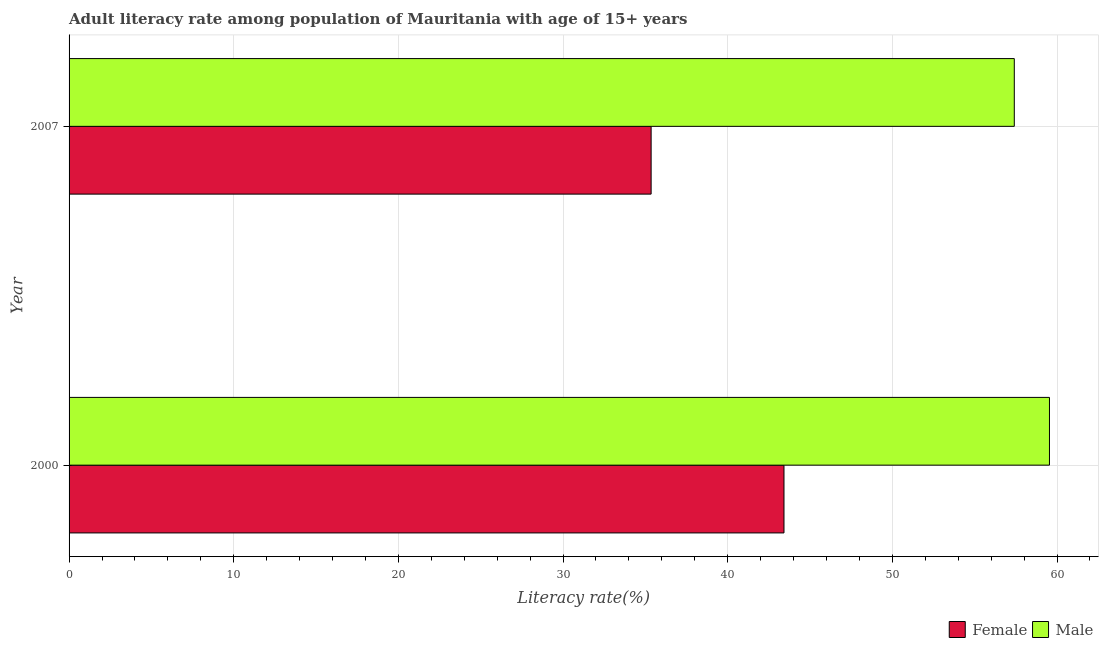How many different coloured bars are there?
Ensure brevity in your answer.  2. Are the number of bars on each tick of the Y-axis equal?
Offer a terse response. Yes. How many bars are there on the 2nd tick from the bottom?
Your response must be concise. 2. What is the label of the 1st group of bars from the top?
Keep it short and to the point. 2007. In how many cases, is the number of bars for a given year not equal to the number of legend labels?
Your response must be concise. 0. What is the male adult literacy rate in 2007?
Provide a succinct answer. 57.4. Across all years, what is the maximum female adult literacy rate?
Provide a succinct answer. 43.42. Across all years, what is the minimum male adult literacy rate?
Keep it short and to the point. 57.4. What is the total male adult literacy rate in the graph?
Your answer should be compact. 116.94. What is the difference between the male adult literacy rate in 2000 and that in 2007?
Ensure brevity in your answer.  2.14. What is the difference between the female adult literacy rate in 2000 and the male adult literacy rate in 2007?
Your response must be concise. -13.99. What is the average male adult literacy rate per year?
Your answer should be compact. 58.47. In the year 2007, what is the difference between the female adult literacy rate and male adult literacy rate?
Keep it short and to the point. -22.06. What is the ratio of the female adult literacy rate in 2000 to that in 2007?
Provide a succinct answer. 1.23. Is the female adult literacy rate in 2000 less than that in 2007?
Offer a very short reply. No. Is the difference between the male adult literacy rate in 2000 and 2007 greater than the difference between the female adult literacy rate in 2000 and 2007?
Ensure brevity in your answer.  No. What does the 2nd bar from the top in 2000 represents?
Your response must be concise. Female. How many years are there in the graph?
Ensure brevity in your answer.  2. Are the values on the major ticks of X-axis written in scientific E-notation?
Your answer should be very brief. No. Does the graph contain any zero values?
Make the answer very short. No. Does the graph contain grids?
Keep it short and to the point. Yes. How are the legend labels stacked?
Keep it short and to the point. Horizontal. What is the title of the graph?
Ensure brevity in your answer.  Adult literacy rate among population of Mauritania with age of 15+ years. Does "International Tourists" appear as one of the legend labels in the graph?
Make the answer very short. No. What is the label or title of the X-axis?
Ensure brevity in your answer.  Literacy rate(%). What is the label or title of the Y-axis?
Offer a very short reply. Year. What is the Literacy rate(%) of Female in 2000?
Your answer should be very brief. 43.42. What is the Literacy rate(%) in Male in 2000?
Provide a succinct answer. 59.54. What is the Literacy rate(%) of Female in 2007?
Ensure brevity in your answer.  35.35. What is the Literacy rate(%) in Male in 2007?
Offer a terse response. 57.4. Across all years, what is the maximum Literacy rate(%) of Female?
Provide a short and direct response. 43.42. Across all years, what is the maximum Literacy rate(%) of Male?
Offer a very short reply. 59.54. Across all years, what is the minimum Literacy rate(%) of Female?
Make the answer very short. 35.35. Across all years, what is the minimum Literacy rate(%) in Male?
Make the answer very short. 57.4. What is the total Literacy rate(%) in Female in the graph?
Your response must be concise. 78.77. What is the total Literacy rate(%) of Male in the graph?
Make the answer very short. 116.94. What is the difference between the Literacy rate(%) of Female in 2000 and that in 2007?
Your response must be concise. 8.07. What is the difference between the Literacy rate(%) of Male in 2000 and that in 2007?
Your answer should be very brief. 2.14. What is the difference between the Literacy rate(%) of Female in 2000 and the Literacy rate(%) of Male in 2007?
Your answer should be very brief. -13.99. What is the average Literacy rate(%) of Female per year?
Provide a short and direct response. 39.38. What is the average Literacy rate(%) in Male per year?
Provide a short and direct response. 58.47. In the year 2000, what is the difference between the Literacy rate(%) of Female and Literacy rate(%) of Male?
Provide a short and direct response. -16.12. In the year 2007, what is the difference between the Literacy rate(%) in Female and Literacy rate(%) in Male?
Your answer should be compact. -22.06. What is the ratio of the Literacy rate(%) in Female in 2000 to that in 2007?
Your answer should be compact. 1.23. What is the ratio of the Literacy rate(%) in Male in 2000 to that in 2007?
Give a very brief answer. 1.04. What is the difference between the highest and the second highest Literacy rate(%) of Female?
Keep it short and to the point. 8.07. What is the difference between the highest and the second highest Literacy rate(%) of Male?
Your answer should be compact. 2.14. What is the difference between the highest and the lowest Literacy rate(%) in Female?
Offer a very short reply. 8.07. What is the difference between the highest and the lowest Literacy rate(%) of Male?
Keep it short and to the point. 2.14. 